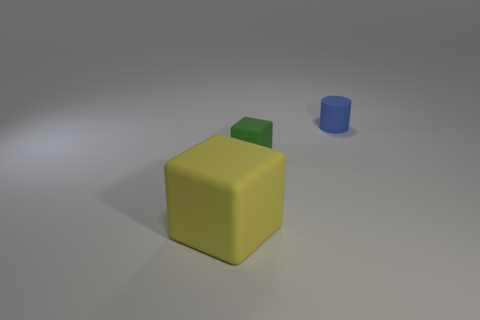Add 1 matte cylinders. How many objects exist? 4 Subtract all cylinders. How many objects are left? 2 Add 3 yellow things. How many yellow things exist? 4 Subtract 0 green balls. How many objects are left? 3 Subtract all large matte balls. Subtract all tiny objects. How many objects are left? 1 Add 1 blue rubber things. How many blue rubber things are left? 2 